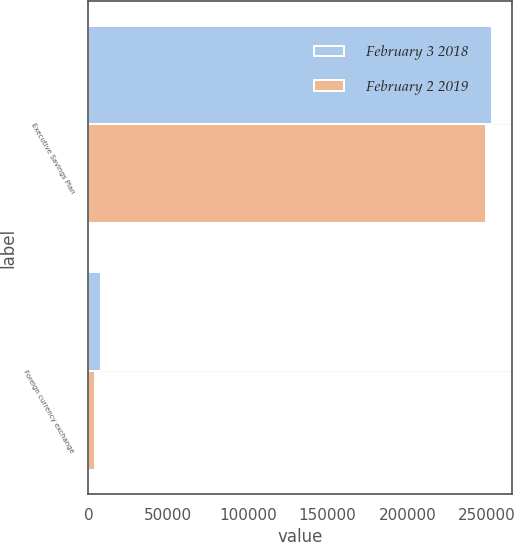<chart> <loc_0><loc_0><loc_500><loc_500><stacked_bar_chart><ecel><fcel>Executive Savings Plan<fcel>Foreign currency exchange<nl><fcel>February 3 2018<fcel>253215<fcel>8136<nl><fcel>February 2 2019<fcel>249045<fcel>4363<nl></chart> 